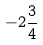<formula> <loc_0><loc_0><loc_500><loc_500>- 2 \frac { 3 } { 4 }</formula> 